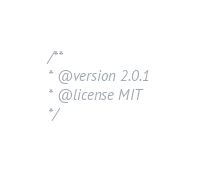<code> <loc_0><loc_0><loc_500><loc_500><_JavaScript_>/** 
* @version 2.0.1
* @license MIT
*/</code> 